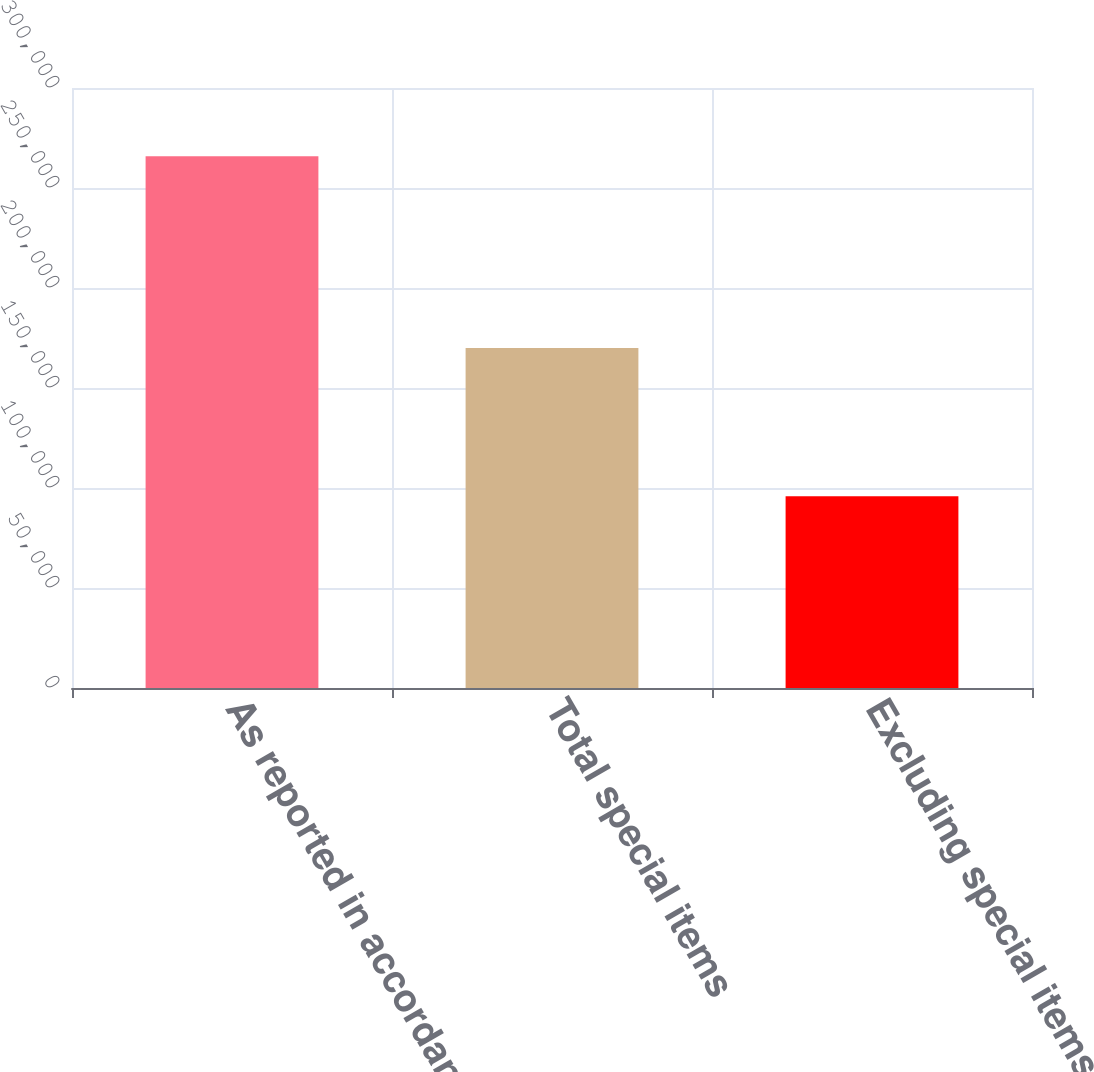Convert chart to OTSL. <chart><loc_0><loc_0><loc_500><loc_500><bar_chart><fcel>As reported in accordance with<fcel>Total special items<fcel>Excluding special items<nl><fcel>265895<fcel>170031<fcel>95864<nl></chart> 